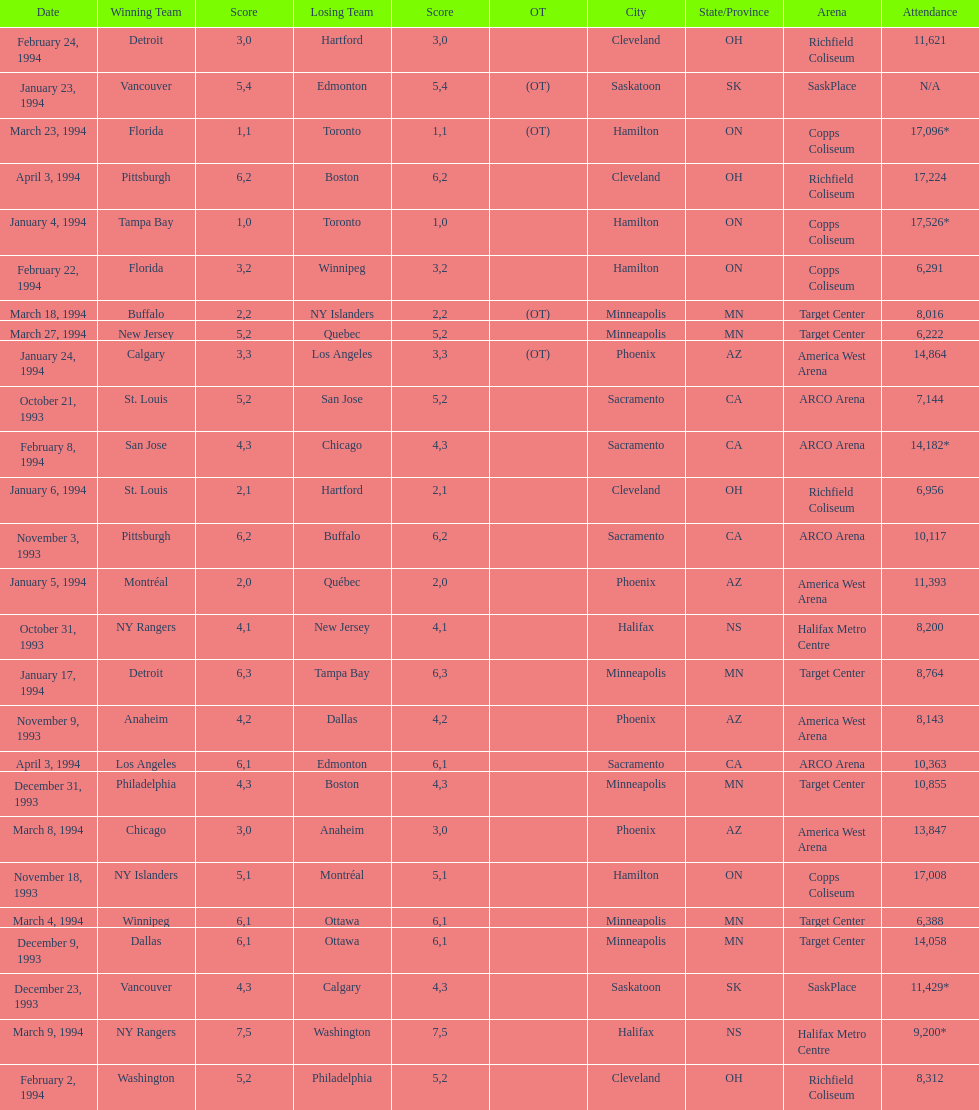How much higher was the attendance at the november 18, 1993 games compared to the november 9th game? 8865. 